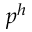<formula> <loc_0><loc_0><loc_500><loc_500>p ^ { h }</formula> 